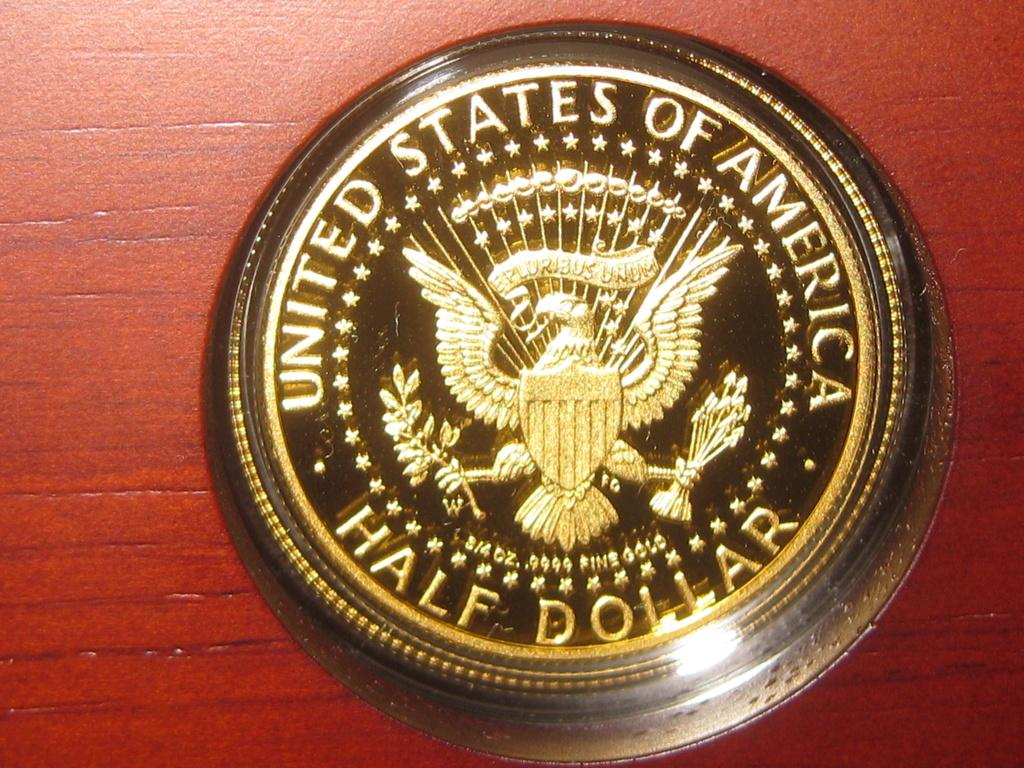<image>
Share a concise interpretation of the image provided. A United States Half Dollar is sitting on a wooden surface. 